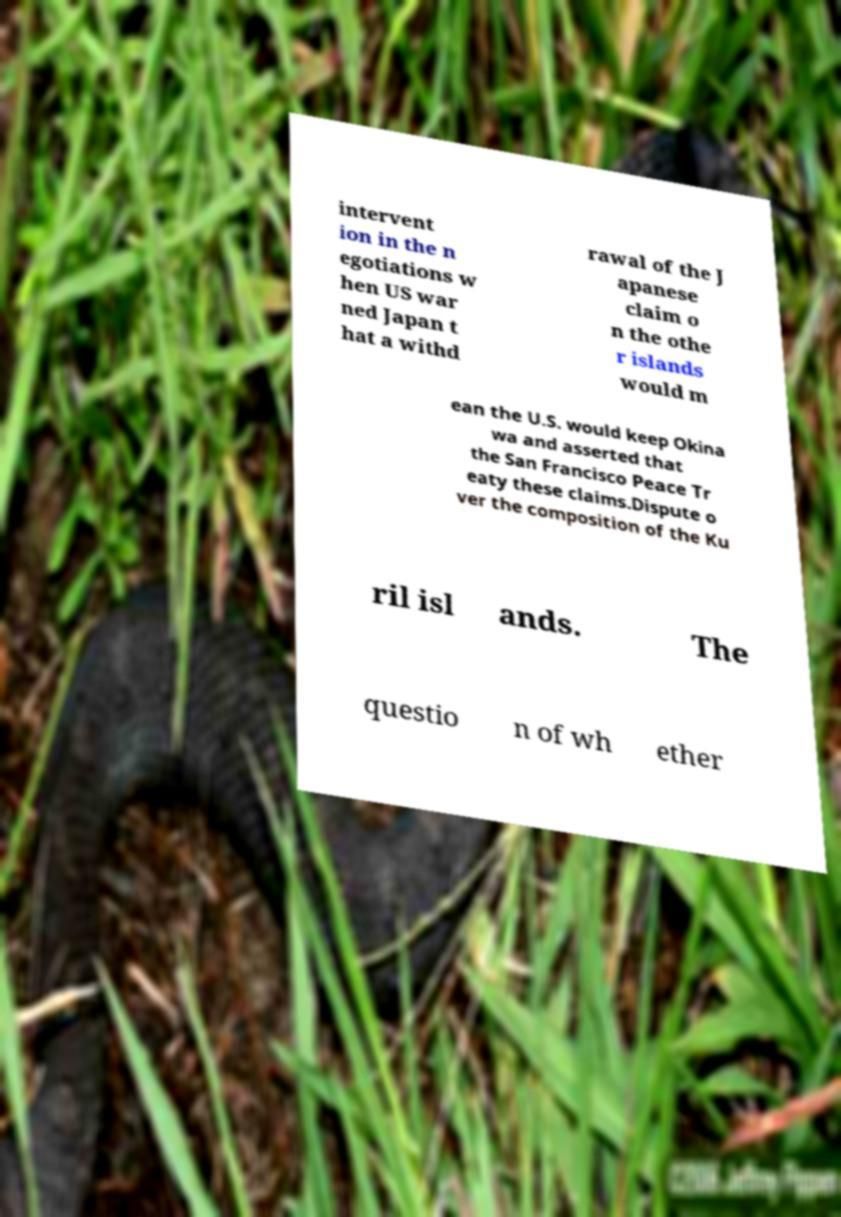For documentation purposes, I need the text within this image transcribed. Could you provide that? intervent ion in the n egotiations w hen US war ned Japan t hat a withd rawal of the J apanese claim o n the othe r islands would m ean the U.S. would keep Okina wa and asserted that the San Francisco Peace Tr eaty these claims.Dispute o ver the composition of the Ku ril isl ands. The questio n of wh ether 